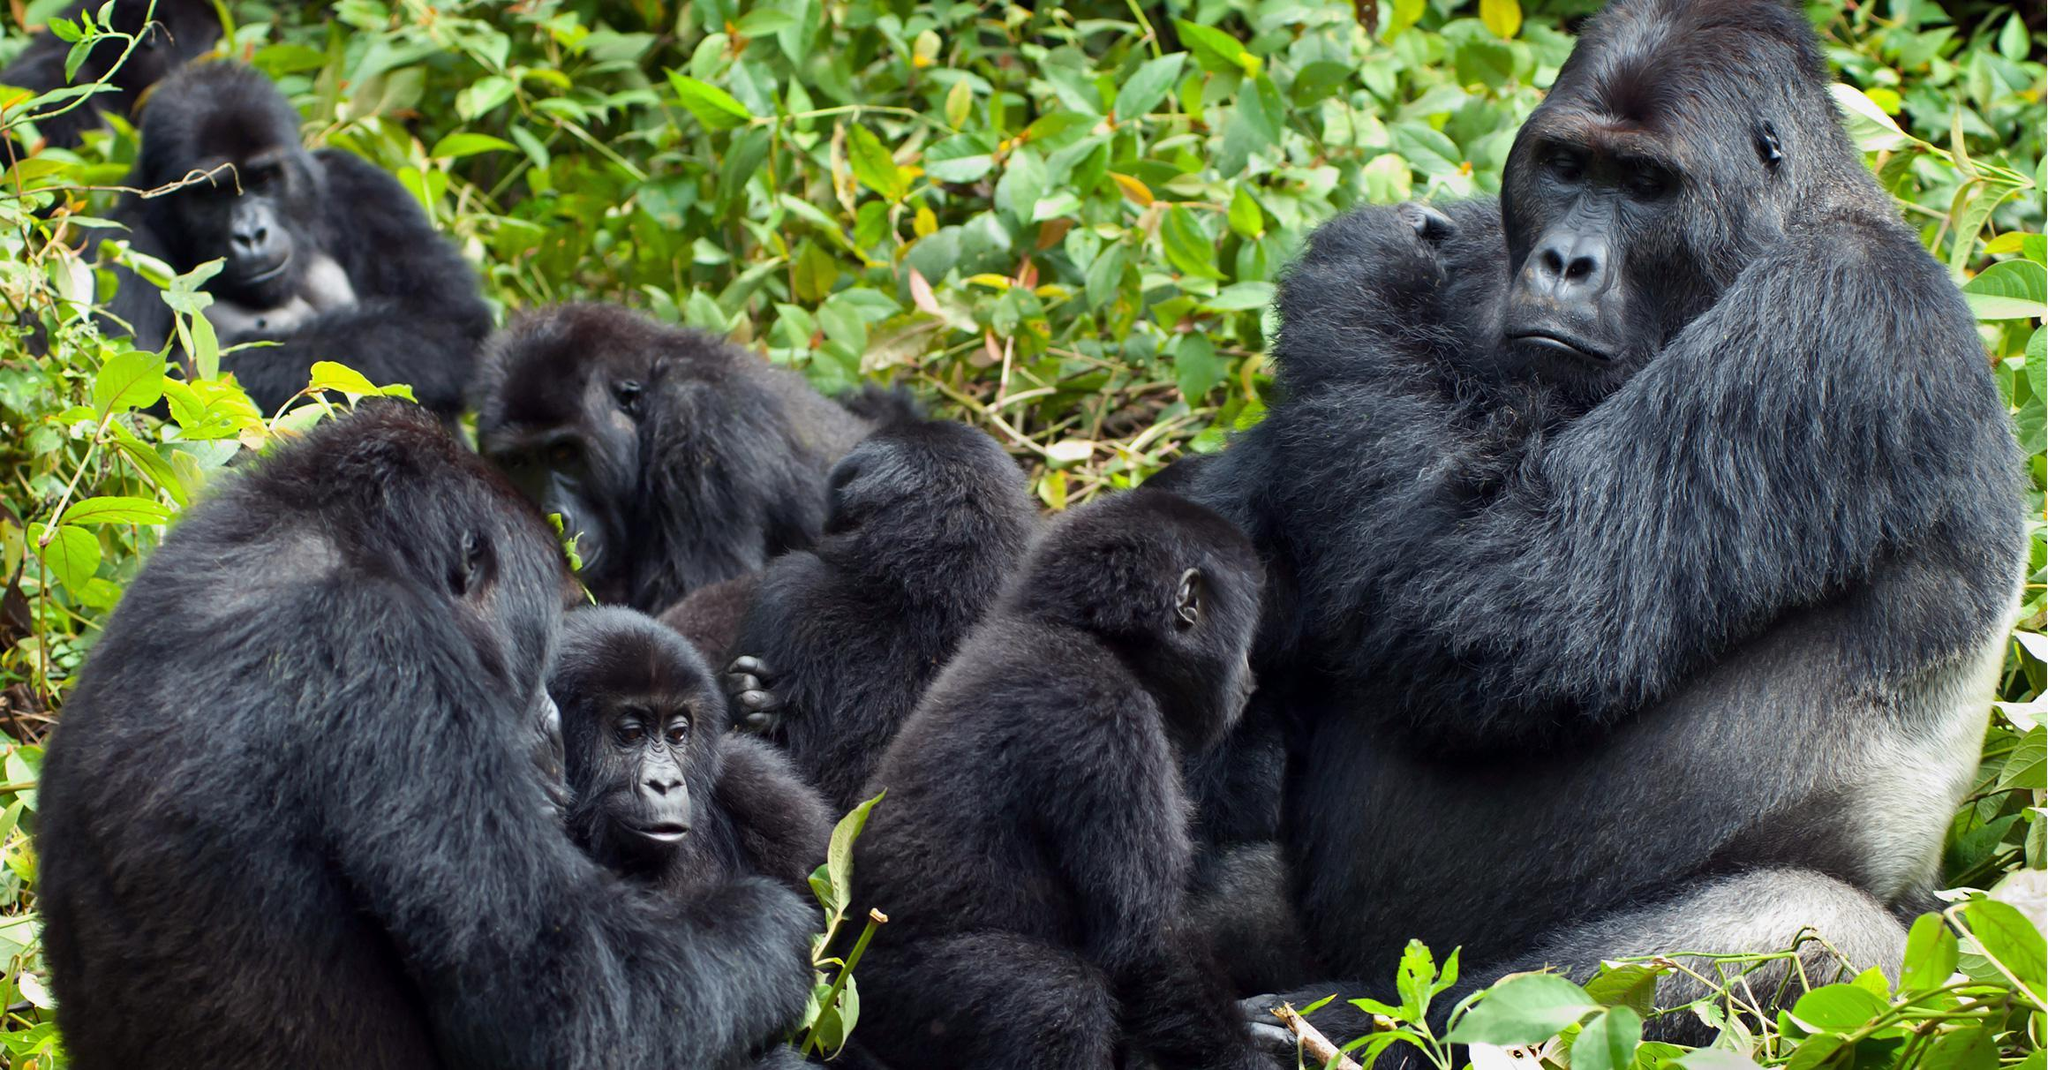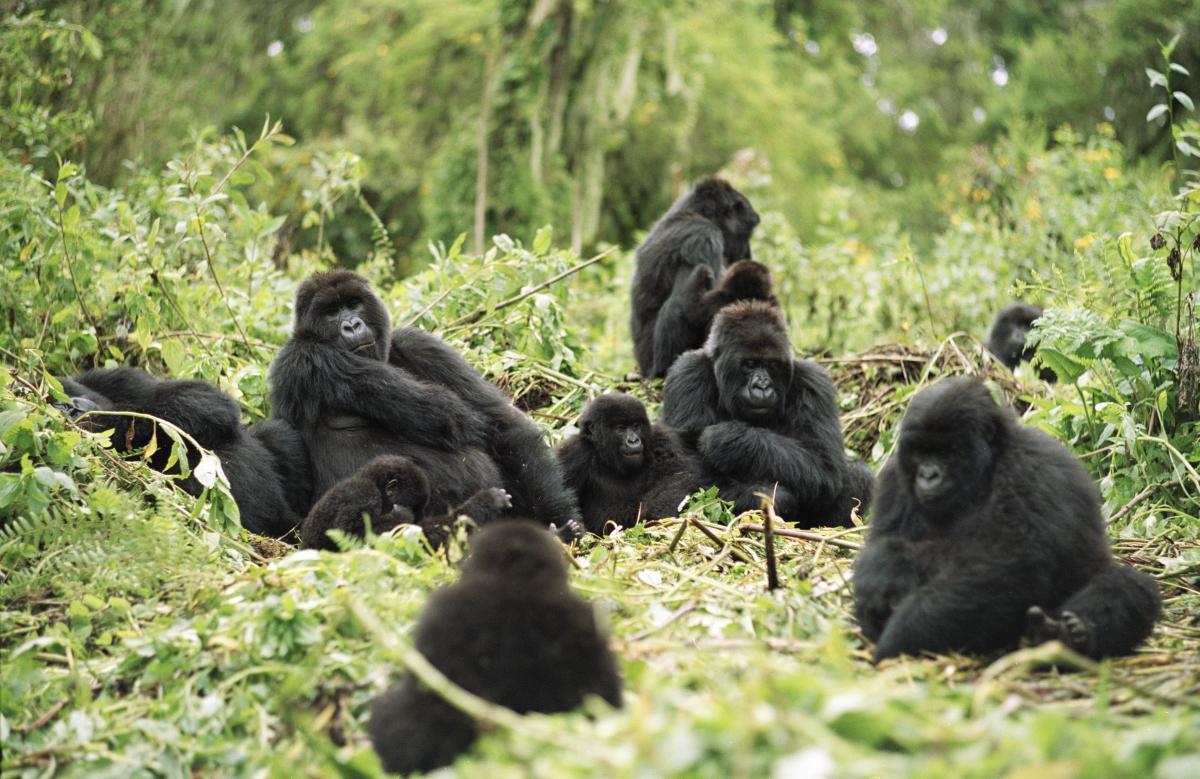The first image is the image on the left, the second image is the image on the right. For the images displayed, is the sentence "The right image contains no more than two gorillas." factually correct? Answer yes or no. No. The first image is the image on the left, the second image is the image on the right. Assess this claim about the two images: "The righthand image contains no more than two gorillas, including one with a big round belly.". Correct or not? Answer yes or no. No. 